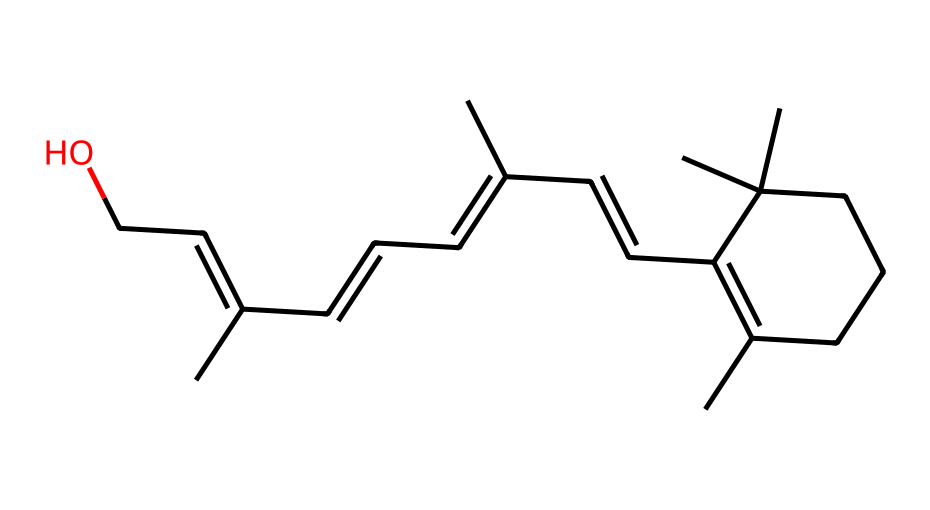What is the main functional group in retinol? The chemical structure contains an -OH (hydroxyl) group, which is indicative of alcohols. This functional group is responsible for some of the properties and reactivity of retinol.
Answer: hydroxyl How many rings are present in the structure of retinol? Inspecting the structure reveals a cyclohexene ring, and after counting, there is only one ring present in the entire molecule.
Answer: one How many double bonds are found in retinol? By analyzing the structure, I can see that there are five double bonds within the linear and cyclic portions of the molecule, counting each pi bond in the alkene groups.
Answer: five Which arrangement, cis or trans, is present in retinol? The configuration of atoms around the double bonds shows that most of them are in a trans arrangement, except for a few that are in a cis configuration, affecting the shape and properties.
Answer: mixed What is the significance of cis-trans isomerism in retinol? Cis-trans isomerism in retinol affects its biological activity, particularly in how well it is utilized by cattle, as the spatial arrangement influences its absorption and functionality.
Answer: biological activity 